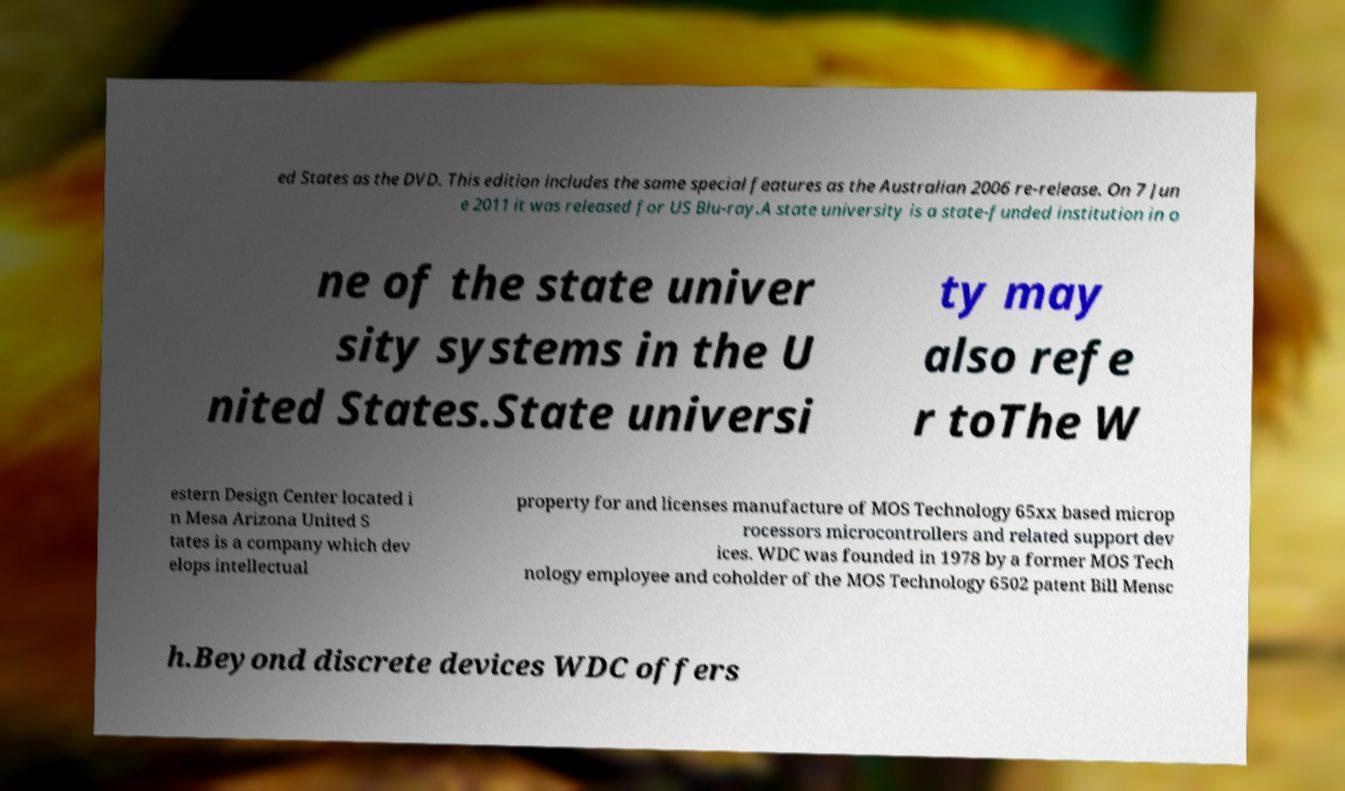Can you accurately transcribe the text from the provided image for me? ed States as the DVD. This edition includes the same special features as the Australian 2006 re-release. On 7 Jun e 2011 it was released for US Blu-ray.A state university is a state-funded institution in o ne of the state univer sity systems in the U nited States.State universi ty may also refe r toThe W estern Design Center located i n Mesa Arizona United S tates is a company which dev elops intellectual property for and licenses manufacture of MOS Technology 65xx based microp rocessors microcontrollers and related support dev ices. WDC was founded in 1978 by a former MOS Tech nology employee and coholder of the MOS Technology 6502 patent Bill Mensc h.Beyond discrete devices WDC offers 